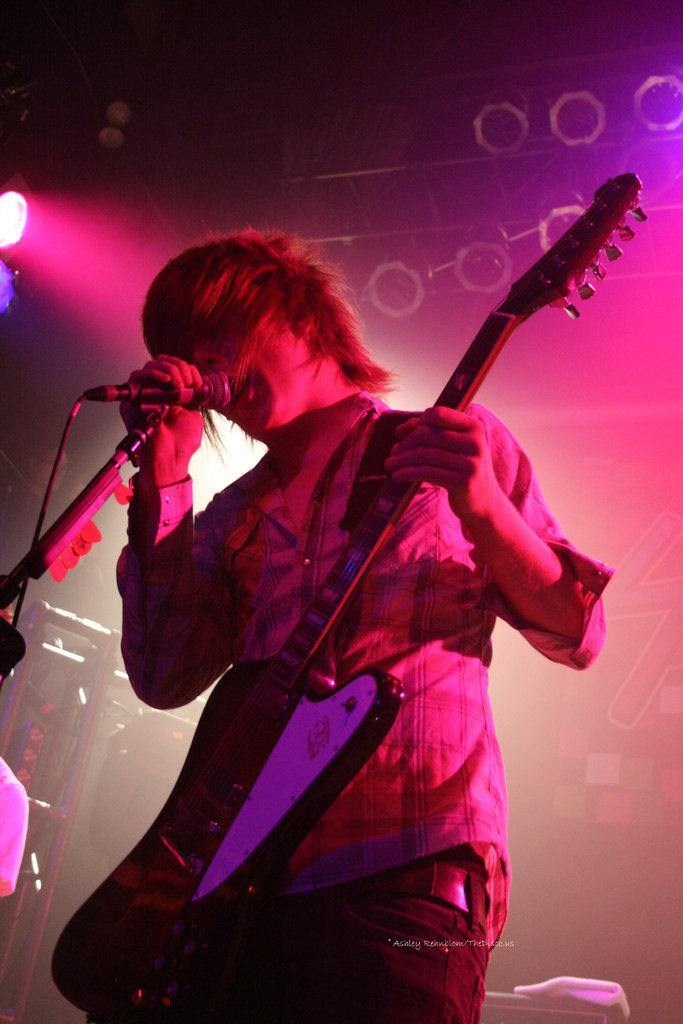Who is the main subject in the image? There is a man in the image. What is the man holding in the image? The man is holding a guitar. What is the man doing with the microphone in the image? The man is singing through a microphone. What can be seen in the background of the image? There are show lights in the background of the image. What type of wax is being used to shape the man's voice in the image? There is no mention of wax or any voice-shaping technique in the image. The man is simply singing through a microphone. 